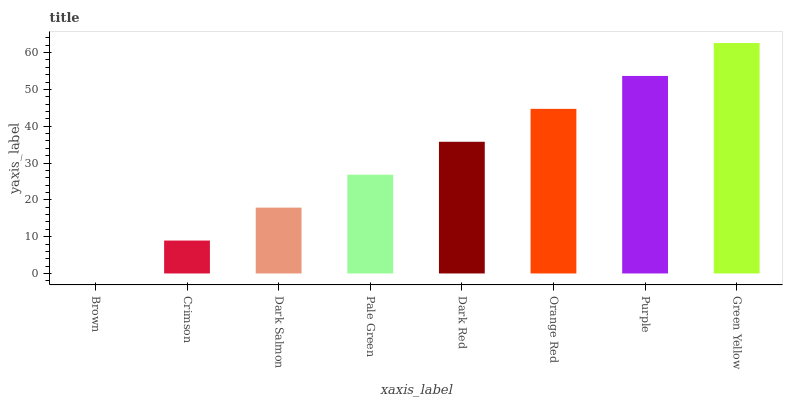Is Brown the minimum?
Answer yes or no. Yes. Is Green Yellow the maximum?
Answer yes or no. Yes. Is Crimson the minimum?
Answer yes or no. No. Is Crimson the maximum?
Answer yes or no. No. Is Crimson greater than Brown?
Answer yes or no. Yes. Is Brown less than Crimson?
Answer yes or no. Yes. Is Brown greater than Crimson?
Answer yes or no. No. Is Crimson less than Brown?
Answer yes or no. No. Is Dark Red the high median?
Answer yes or no. Yes. Is Pale Green the low median?
Answer yes or no. Yes. Is Crimson the high median?
Answer yes or no. No. Is Crimson the low median?
Answer yes or no. No. 